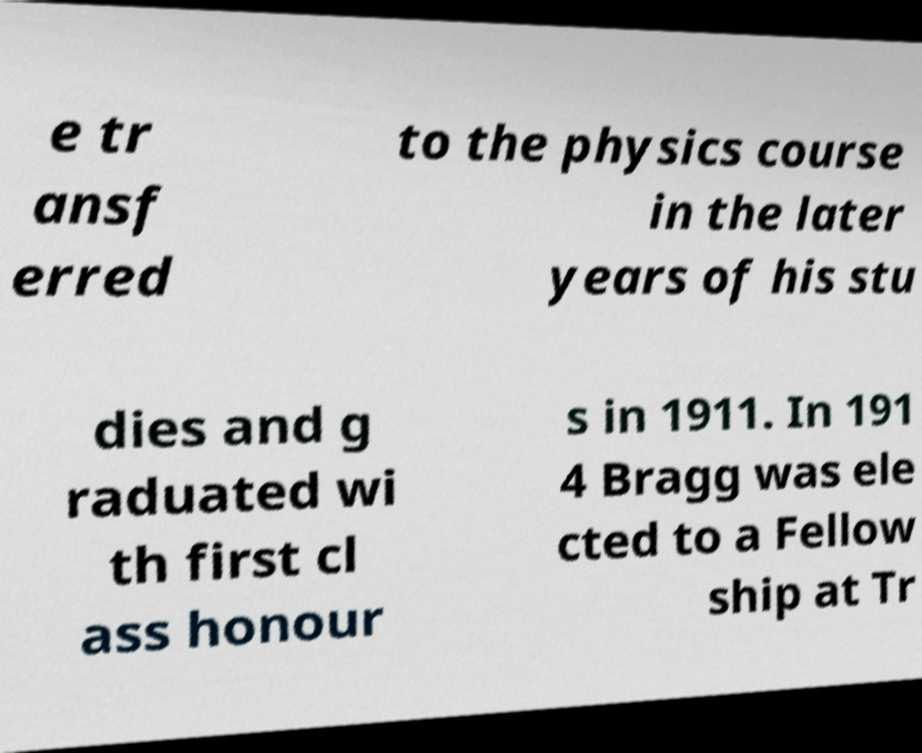Could you assist in decoding the text presented in this image and type it out clearly? e tr ansf erred to the physics course in the later years of his stu dies and g raduated wi th first cl ass honour s in 1911. In 191 4 Bragg was ele cted to a Fellow ship at Tr 